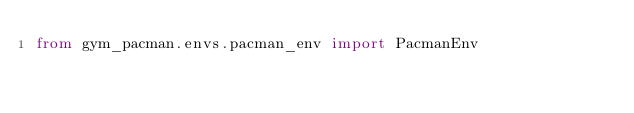<code> <loc_0><loc_0><loc_500><loc_500><_Python_>from gym_pacman.envs.pacman_env import PacmanEnv
</code> 